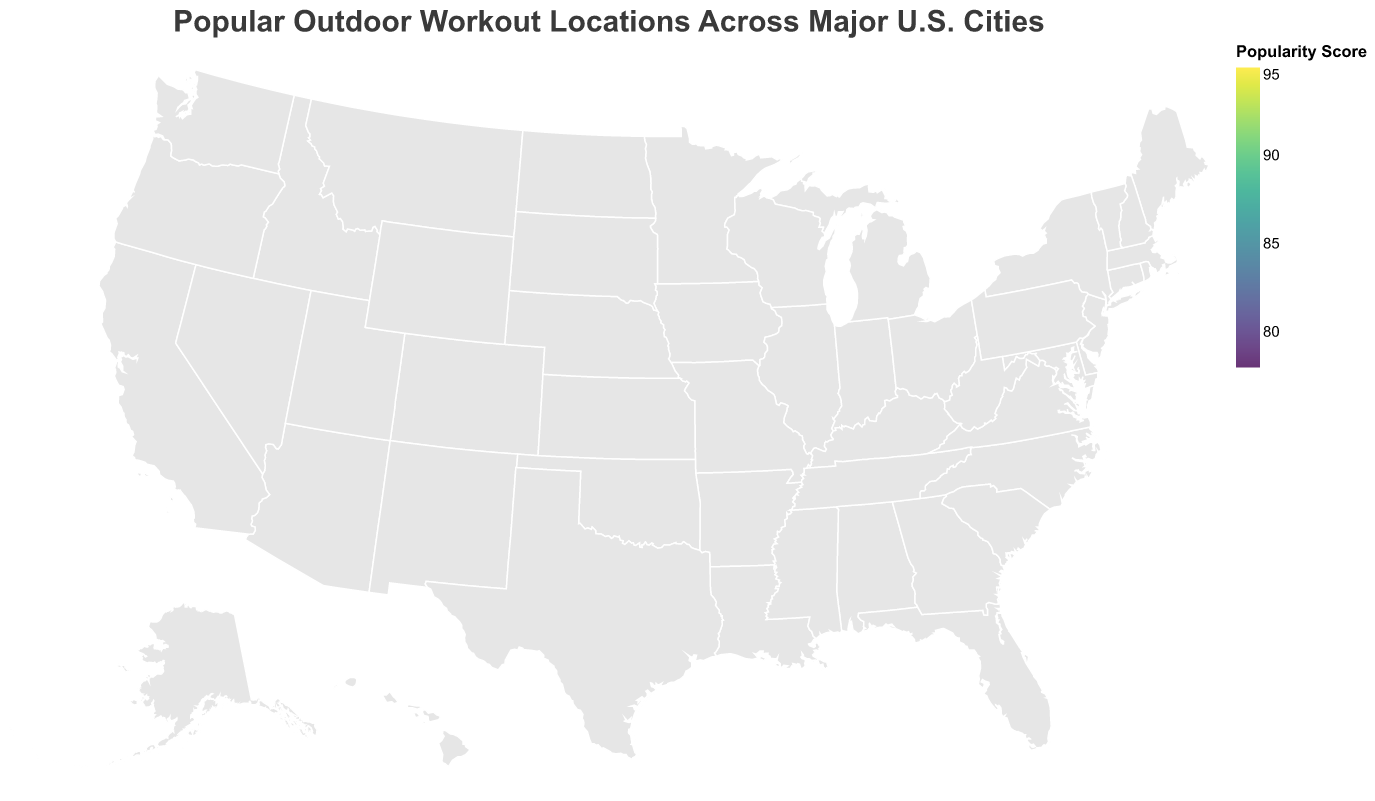What is the title of the plot? The title is displayed at the top of the map and summarizes what the figure is about. It reads: "Popular Outdoor Workout Locations Across Major U.S. Cities".
Answer: Popular Outdoor Workout Locations Across Major U.S. Cities Which location has the highest popularity score? By observing the color intensity and size of the circles, we see that Central Park in New York has the largest circle with the highest color intensity, indicating it has the highest popularity score.
Answer: Central Park How many cities are represented on the map? By counting the number of circles (each representing a city) on the map, we can determine there are 15 cities.
Answer: 15 What is the popularity score of Lakefront Trail in Chicago? By referring to the tooltip information for the circle corresponding to Chicago, it shows the popularity score of Lakefront Trail is 92.
Answer: 92 Which location has the lowest popularity score? By observing the smallest and least intense circle on the map, we can identify that Papago Park in Phoenix has the lowest popularity score.
Answer: Papago Park What is the average popularity score of all locations? To find the average, sum the popularity scores of all locations and divide by the number of locations. The sum is 78 + 79 + 80 + 81 + 82 + 83 + 84 + 85 + 86 + 87 + 88 + 89 + 90 + 92 + 95 = 1319. Since there are 15 locations, the average is 1319 / 15 = approximately 87.93.
Answer: 87.93 How does the popularity of Runyon Canyon in Los Angeles compare to Golden Gate Park in San Francisco? By checking the circles for Los Angeles and San Francisco, Runyon Canyon has a popularity score of 88, while Golden Gate Park has a popularity score of 90. Thus, Runyon Canyon is less popular than Golden Gate Park.
Answer: Less popular Which city has the most popular workout location in the northeastern U.S.? From the northeastern cities represented (New York, Boston, Washington D.C., Philadelphia), New York's Central Park has the highest popularity score at 95.
Answer: New York How do the popularity scores of locations in Texas compare? Texas has two cities listed: Austin and Houston. Austin's popularity score for Lady Bird Lake Trail is 89, while Houston's Memorial Park has a score of 79. Therefore, Austin's location is more popular than Houston's.
Answer: Austin is more popular Is there a general trend in the popularity scores across the U.S.? By evaluating the sizes and color intensity of the circles spread across the U.S., there is no apparent geographical trend (north-south or east-west) indicating a variation in popularity uniformly across different regions.
Answer: No apparent trend 